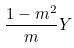<formula> <loc_0><loc_0><loc_500><loc_500>\frac { 1 - m ^ { 2 } } { m } Y</formula> 